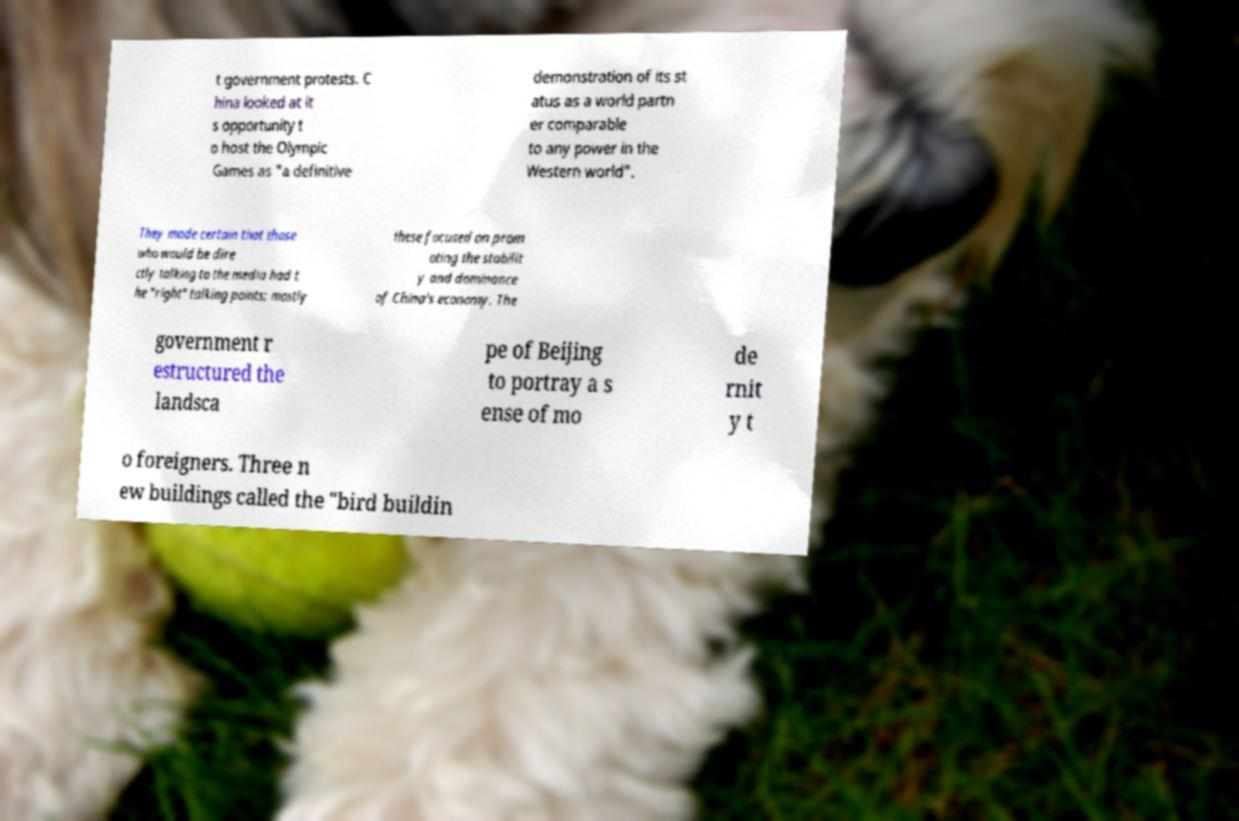Please identify and transcribe the text found in this image. t government protests. C hina looked at it s opportunity t o host the Olympic Games as "a definitive demonstration of its st atus as a world partn er comparable to any power in the Western world". They made certain that those who would be dire ctly talking to the media had t he "right" talking points; mostly these focused on prom oting the stabilit y and dominance of China's economy. The government r estructured the landsca pe of Beijing to portray a s ense of mo de rnit y t o foreigners. Three n ew buildings called the "bird buildin 